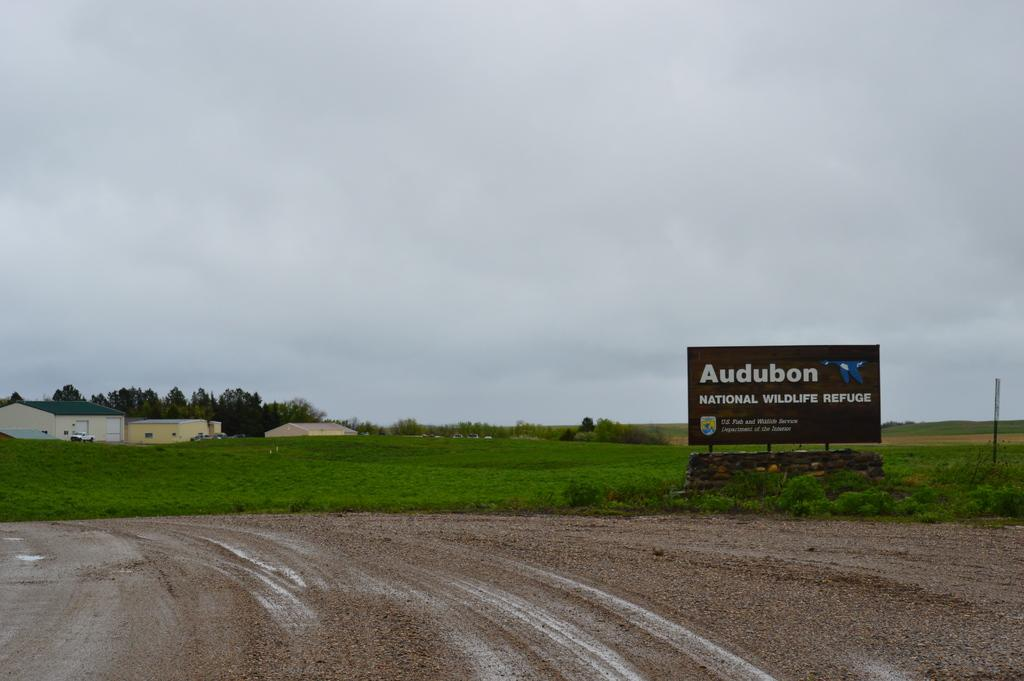What is the main object in the image? There is a board in the image. What type of natural elements can be seen in the image? There are plants, grass, and trees in the image. What type of structures are visible in the image? There are houses in the image. What is visible in the background of the image? The sky is visible in the background of the image. Is there a volcano erupting in the image? No, there is no volcano present in the image. Can you see any wounds on the plants in the image? There is no mention of any wounds on the plants in the image, and plants do not have the ability to experience wounds like living organisms. 